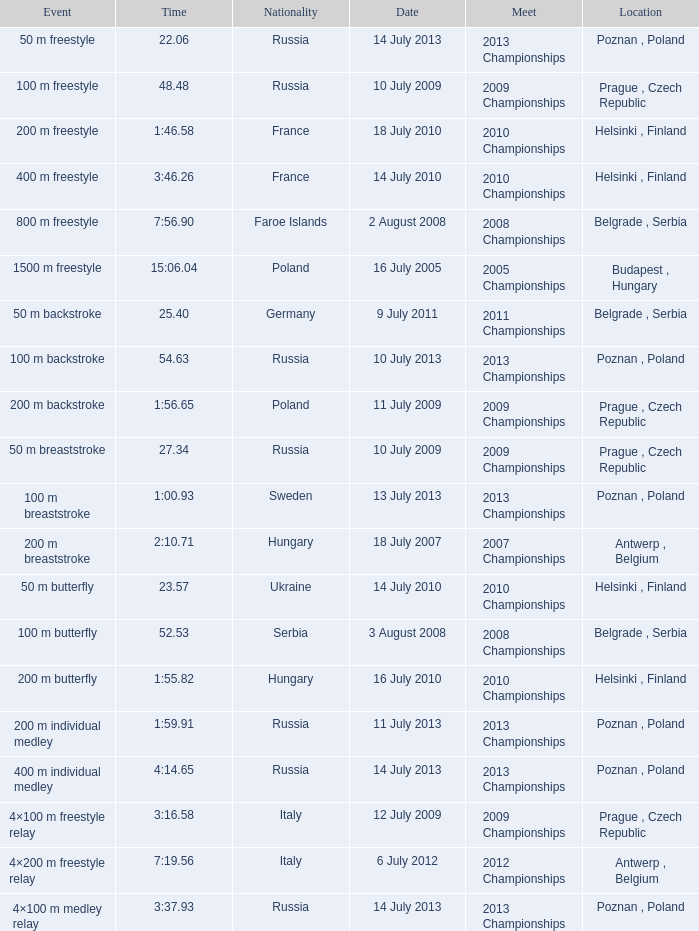Where were the 2008 championships with a time of 7:56.90 held? Belgrade , Serbia. 